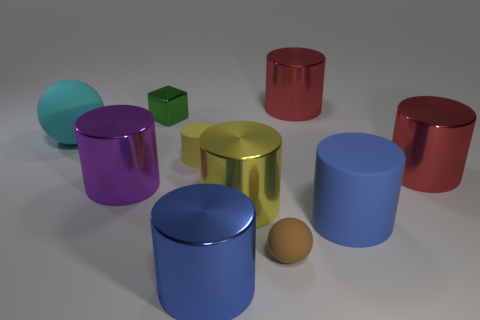In relation to the scene composition, what can you tell about the foreground and background elements? The foreground of the image is occupied by a diverse arrangement of colorful cylinders and a sphere which draw immediate attention due to their bright colors and prominent positioning. The background, however, is quite plain and consists of a nondescript, matte surface that offers a minimalistic contrast to the vibrancy of the shapes. 